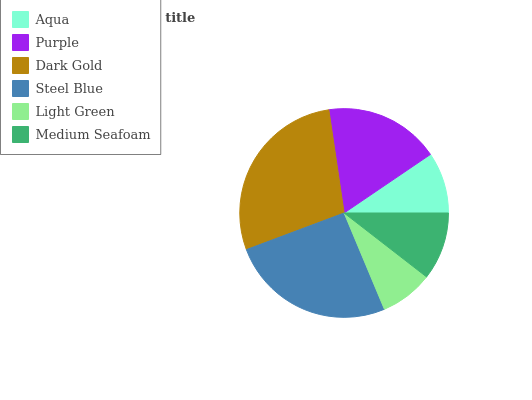Is Light Green the minimum?
Answer yes or no. Yes. Is Dark Gold the maximum?
Answer yes or no. Yes. Is Purple the minimum?
Answer yes or no. No. Is Purple the maximum?
Answer yes or no. No. Is Purple greater than Aqua?
Answer yes or no. Yes. Is Aqua less than Purple?
Answer yes or no. Yes. Is Aqua greater than Purple?
Answer yes or no. No. Is Purple less than Aqua?
Answer yes or no. No. Is Purple the high median?
Answer yes or no. Yes. Is Medium Seafoam the low median?
Answer yes or no. Yes. Is Aqua the high median?
Answer yes or no. No. Is Aqua the low median?
Answer yes or no. No. 